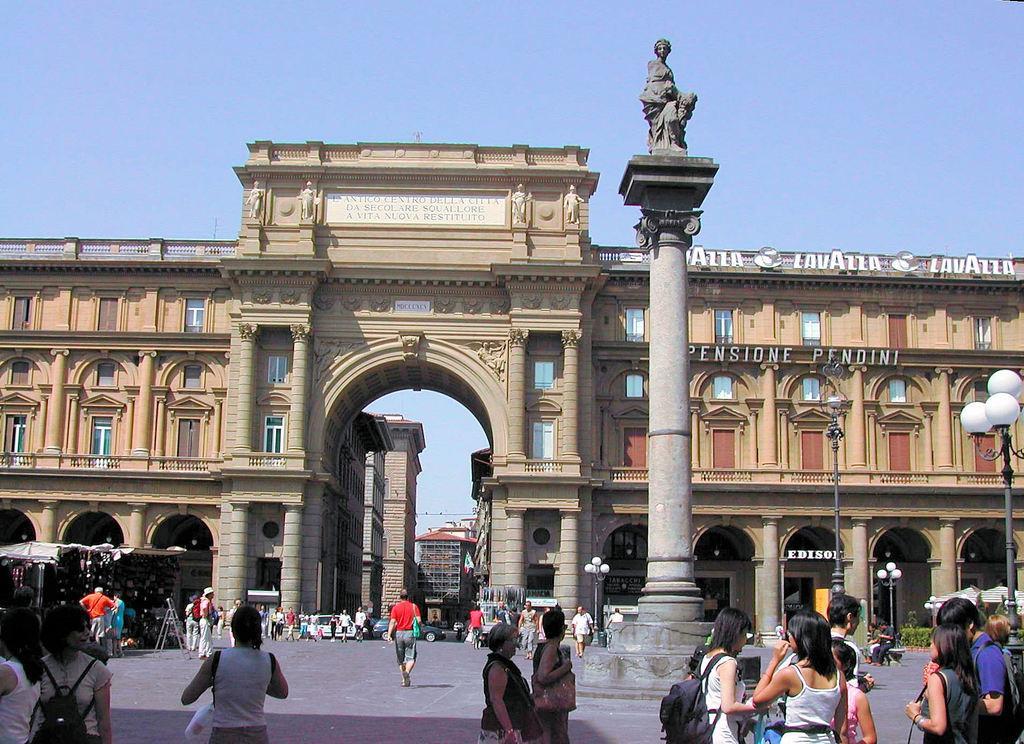In one or two sentences, can you explain what this image depicts? In this image there are a few people walking on the streets, behind them there are buildings. 